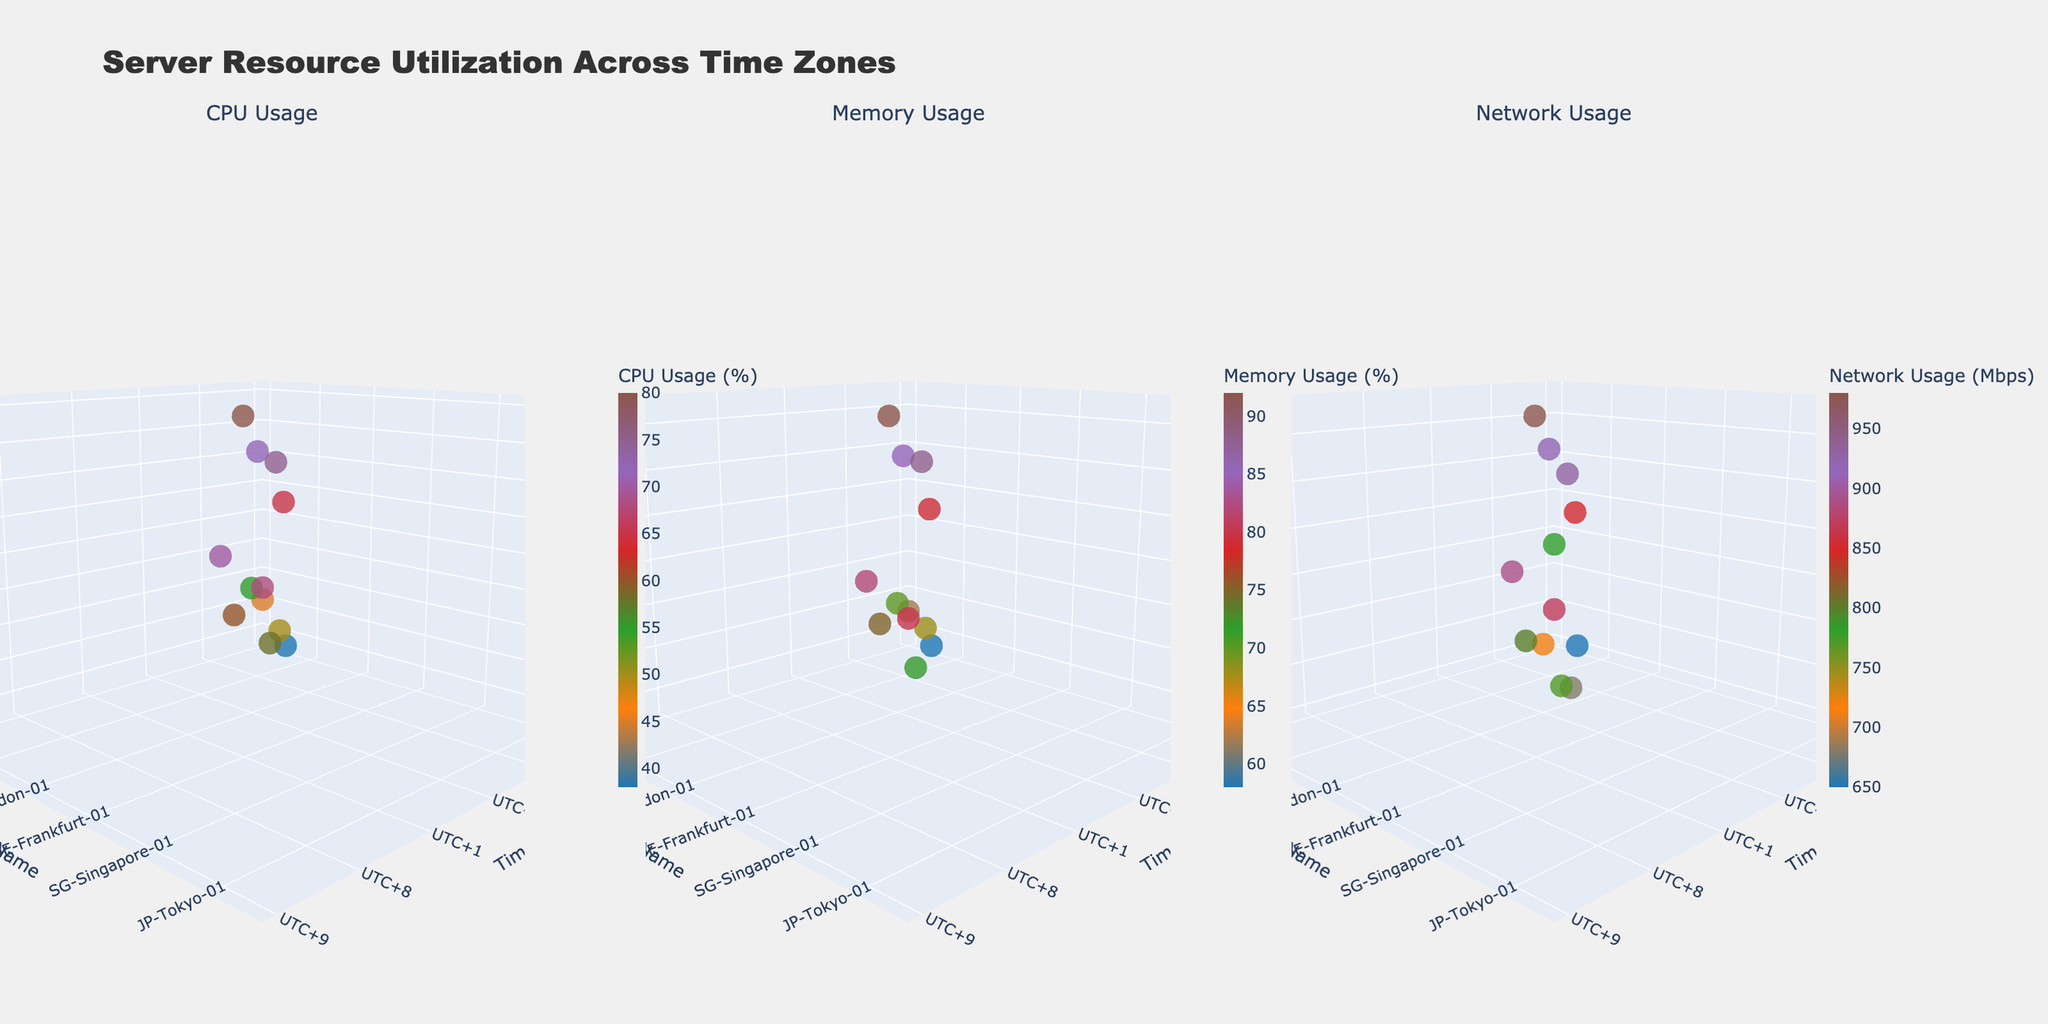What is the title of the figure? The title of the figure is usually displayed at the top center of the plot, often in larger and bold font compared to other text elements.
Answer: Server Resource Utilization Across Time Zones How many servers are displayed in the figure? Each server's name is shown on the y-axis of the plots, and the count of unique names gives the number of servers.
Answer: 12 Which server has the highest CPU usage? Look for the marker with the highest z-value in the 'CPU Usage' subplot. From the z-axis labels and server names, locate the server with the highest point.
Answer: DE-Frankfurt-01 Compare CPU usage between US-East-01 and JP-Tokyo-01. Which server has higher usage? Locate the points representing US-East-01 and JP-Tokyo-01 in the 'CPU Usage' subplot, then compare their z-values to determine which is higher.
Answer: US-East-01 Which time zone has the lowest network usage? Identify the markers representing each time zone in the 'Network Usage' subplot and find the marker with the lowest z-value.
Answer: UTC-8 What is the average memory usage for servers in UTC+1? Identify the servers in UTC+1 time zone (DE-Frankfurt-01 and DE-Frankfurt-02) in the 'Memory Usage' subplot, sum their memory usages, and divide by the number of servers.
Answer: 90 Which server has the lowest memory usage, and what is its value? Find the marker with the lowest z-value in the 'Memory Usage' subplot and note the server name and the corresponding z-value.
Answer: US-West-02, 58 Compare network usage between UK-London-01 and SG-Singapore-02. Which server has higher usage? Locate the points for UK-London-01 and SG-Singapore-02 in the 'Network Usage' subplot and compare their z-values.
Answer: UK-London-01 Is there a noticeable trend in CPU usage across different time zones? Scan the 'CPU Usage' subplot for a pattern in marker positions along the x-axis (time zones) to see if there's an increasing or decreasing trend.
Answer: No clear trend Which time zone has the highest range of memory usage values? Identify the maximum and minimum z-values for each time zone in the 'Memory Usage' subplot, then calculate the range (max - min) and compare across time zones.
Answer: UTC+1 